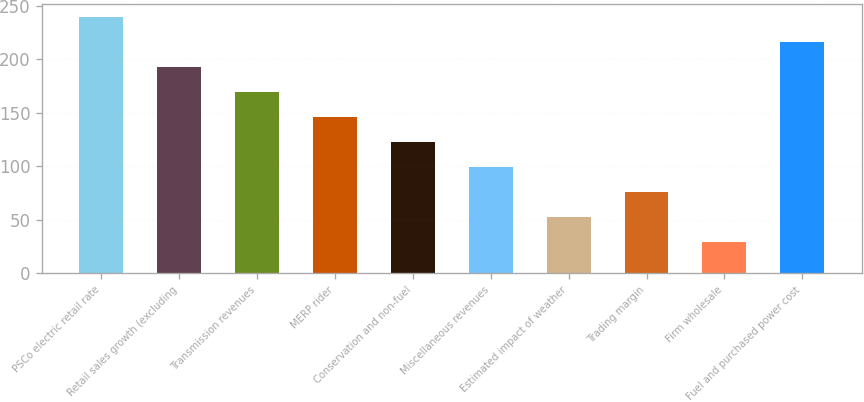<chart> <loc_0><loc_0><loc_500><loc_500><bar_chart><fcel>PSCo electric retail rate<fcel>Retail sales growth (excluding<fcel>Transmission revenues<fcel>MERP rider<fcel>Conservation and non-fuel<fcel>Miscellaneous revenues<fcel>Estimated impact of weather<fcel>Trading margin<fcel>Firm wholesale<fcel>Fuel and purchased power cost<nl><fcel>240<fcel>193.2<fcel>169.8<fcel>146.4<fcel>123<fcel>99.6<fcel>52.8<fcel>76.2<fcel>29.4<fcel>216.6<nl></chart> 